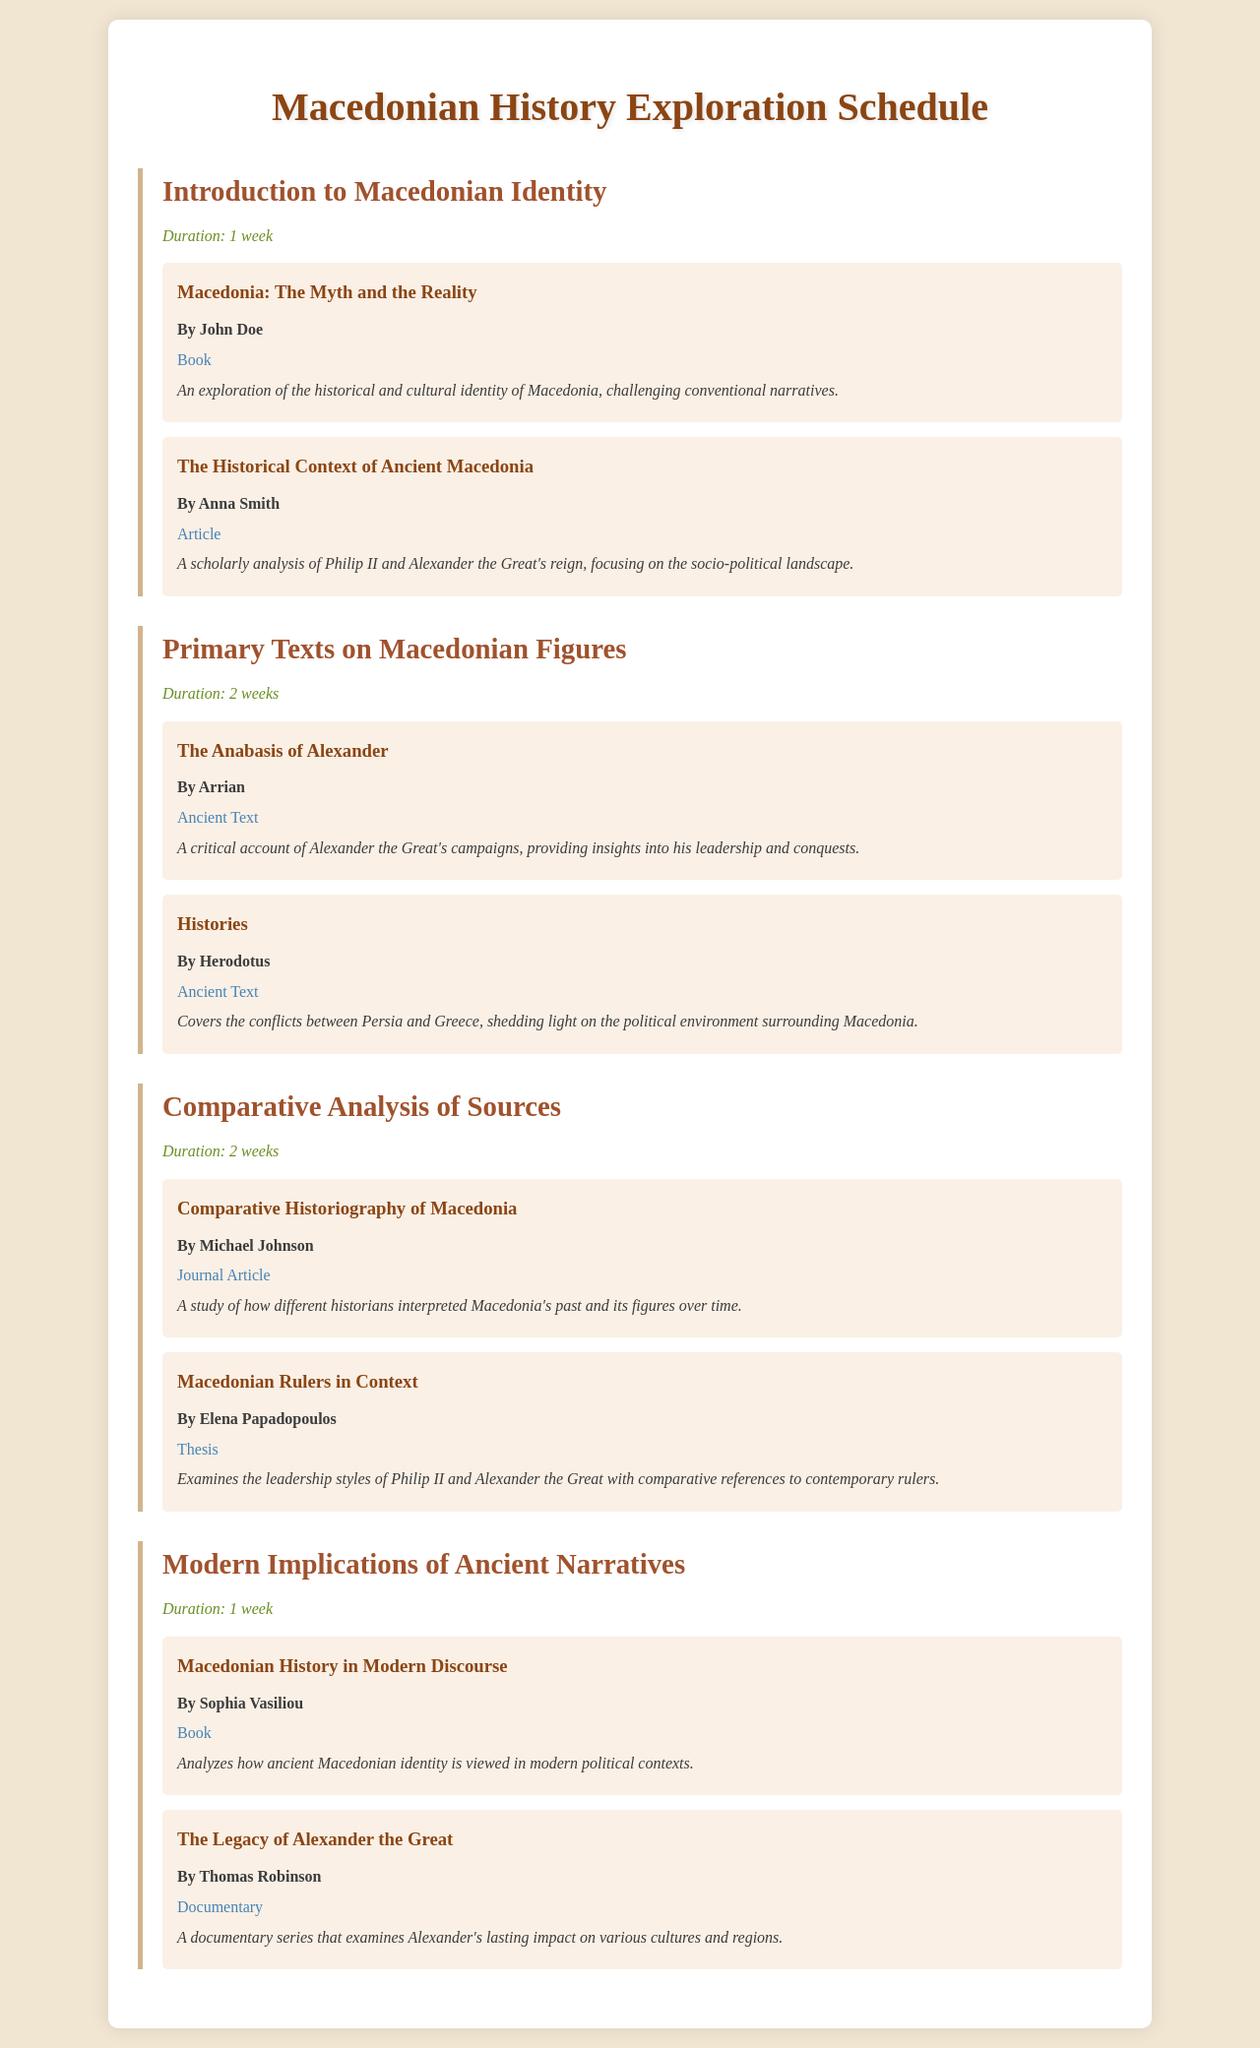What is the duration of the "Introduction to Macedonian Identity"? The duration is mentioned as 1 week in the schedule.
Answer: 1 week Who is the author of "The Anabasis of Alexander"? The author of this text is specifically noted in the document as Arrian.
Answer: Arrian What type of material is "Macedonian Rulers in Context"? The type of material is indicated as a thesis within the content.
Answer: Thesis How many weeks is the "Comparative Analysis of Sources" scheduled for? The schedule clearly states that this section lasts for 2 weeks.
Answer: 2 weeks What is the title of the book by John Doe? The title provided in the material is "Macedonia: The Myth and the Reality."
Answer: Macedonia: The Myth and the Reality What is the focus of Anna Smith's article? The focus is described as a scholarly analysis of Philip II and Alexander the Great's reign.
Answer: Philip II and Alexander the Great's reign Who authored "Macedonian History in Modern Discourse"? Sophia Vasiliou is identified as the author of this book in the document.
Answer: Sophia Vasiliou What type of source is "The Legacy of Alexander the Great"? This source is classified as a documentary according to the provided information.
Answer: Documentary 